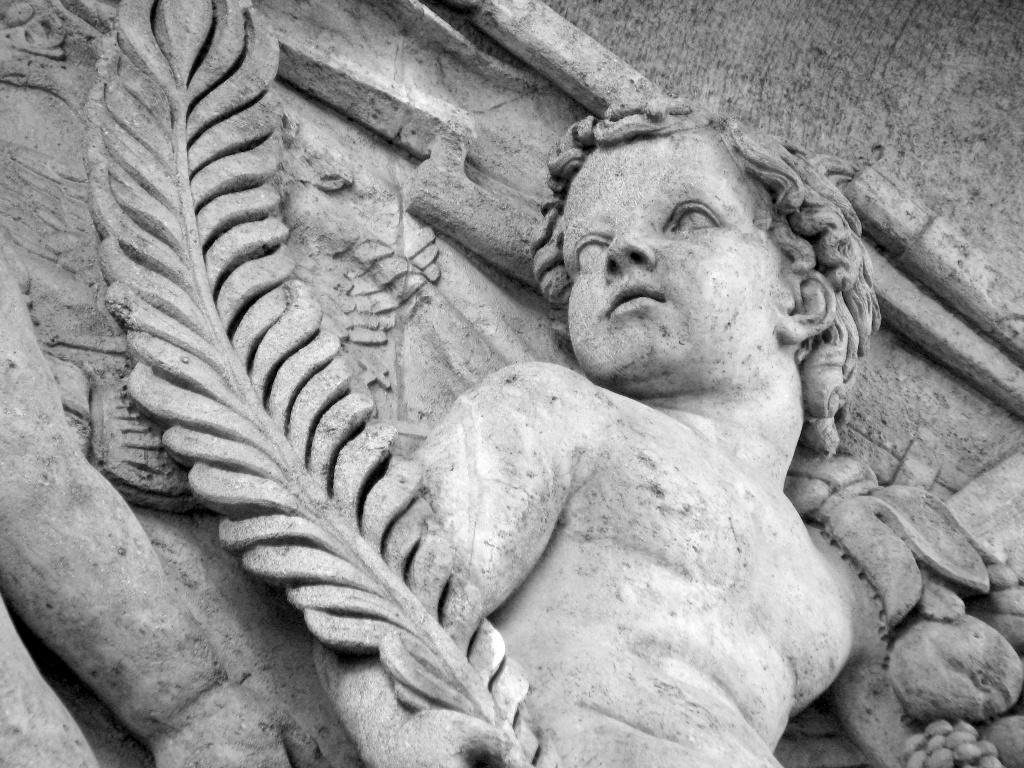What is depicted in the image? There are statues of two people in the image. What is the color of the statues? The statues are in ash color. What type of noise can be heard coming from the kettle in the image? There is no kettle present in the image, so it is not possible to determine what noise might be heard. 